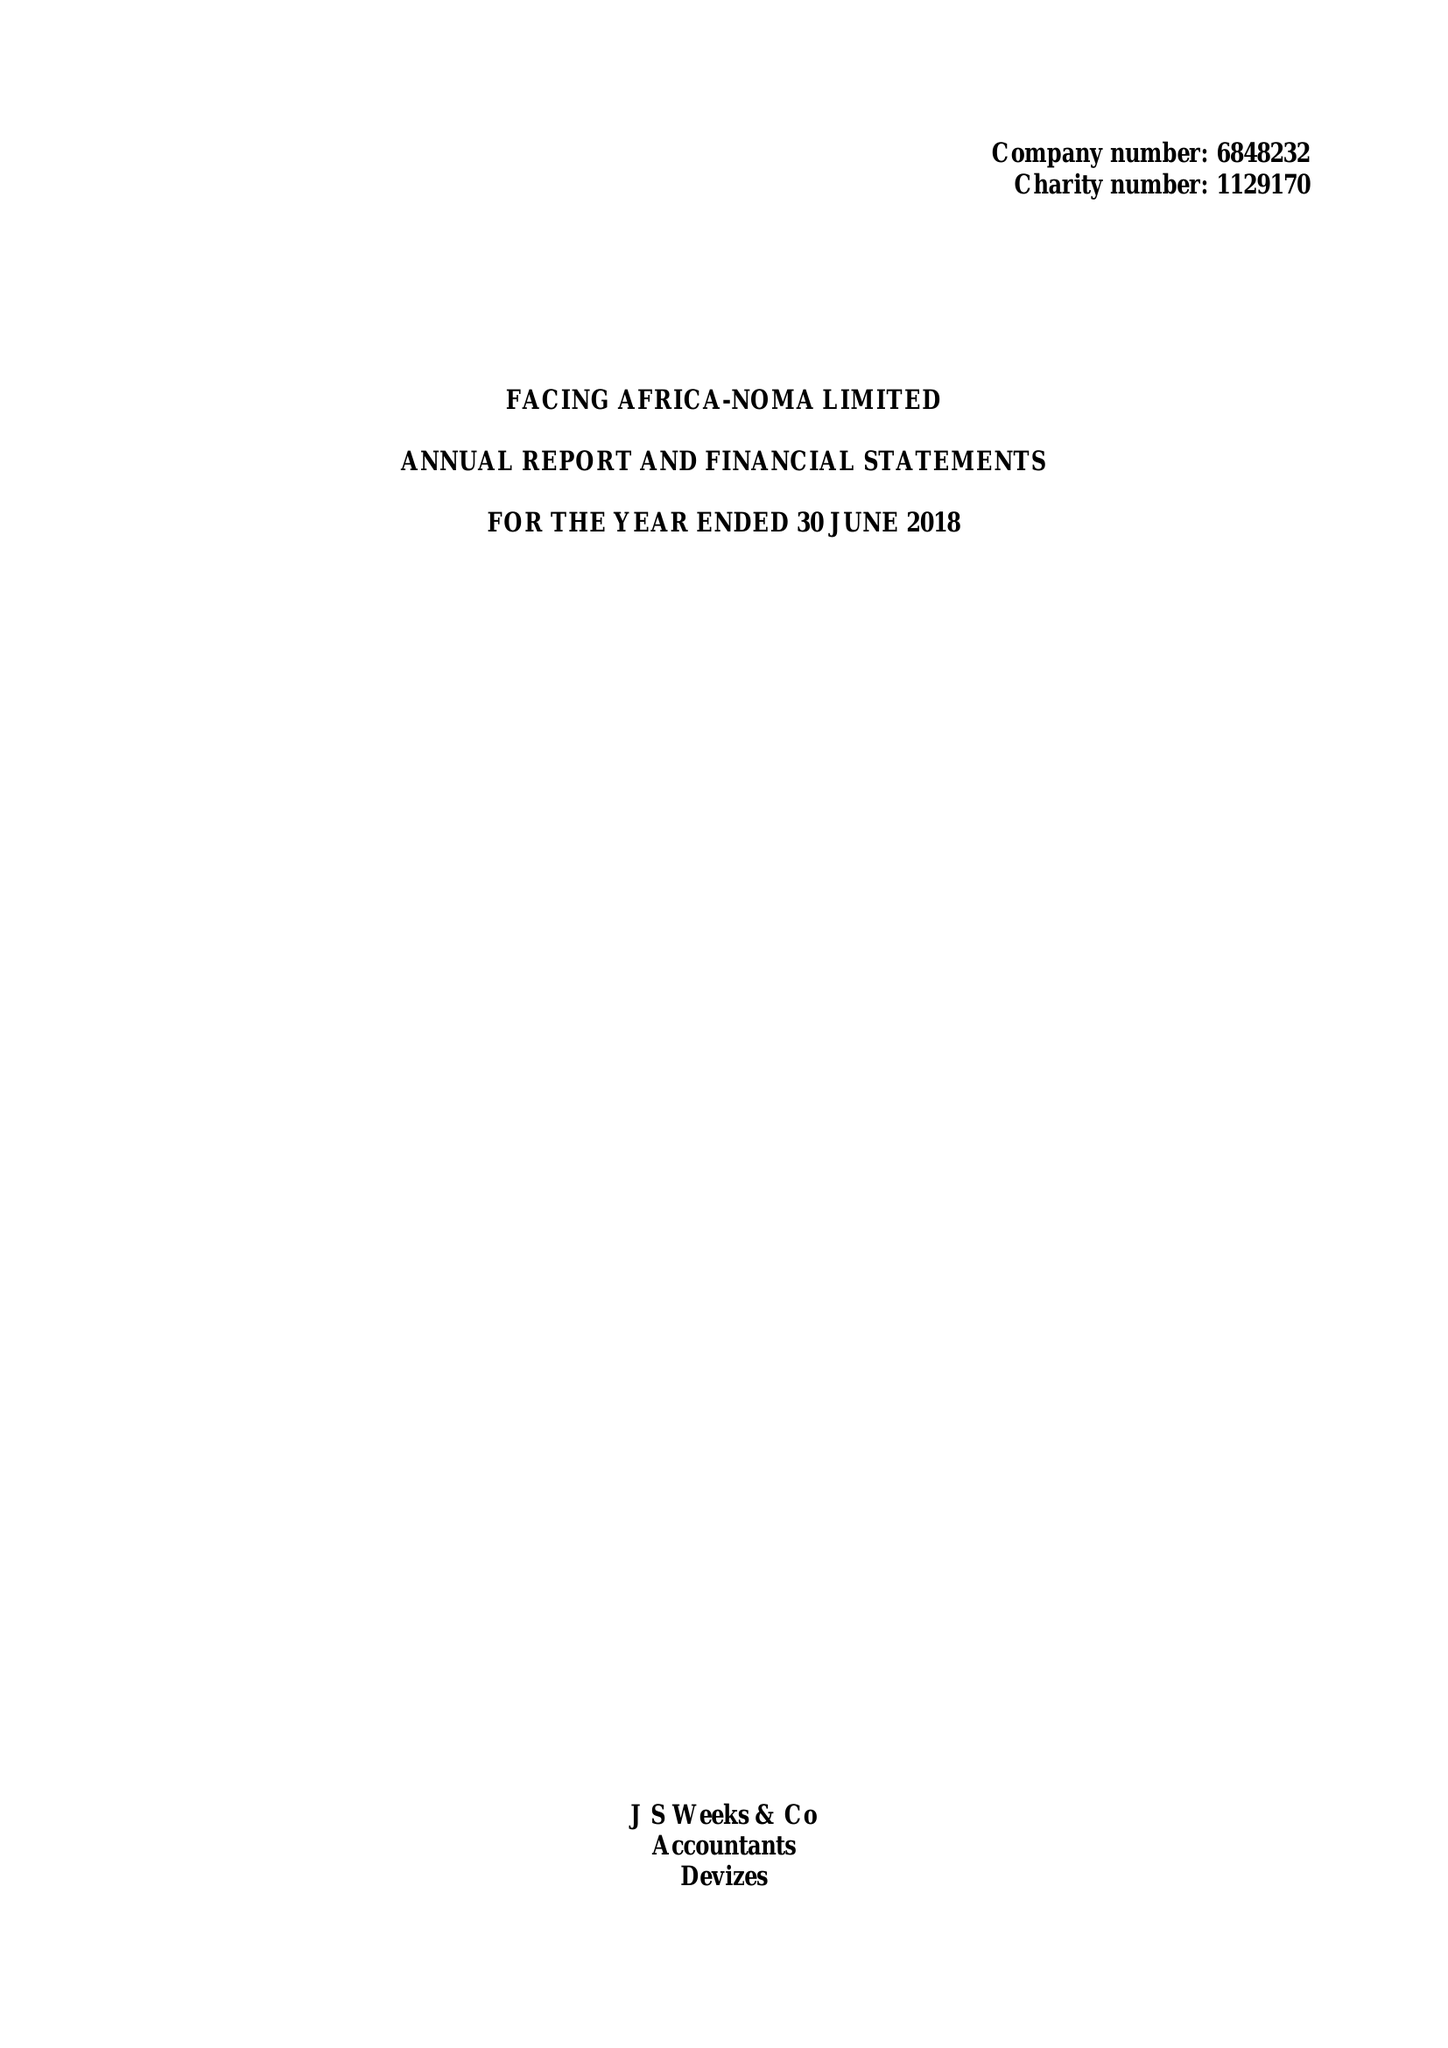What is the value for the address__post_town?
Answer the question using a single word or phrase. DEVIZES 